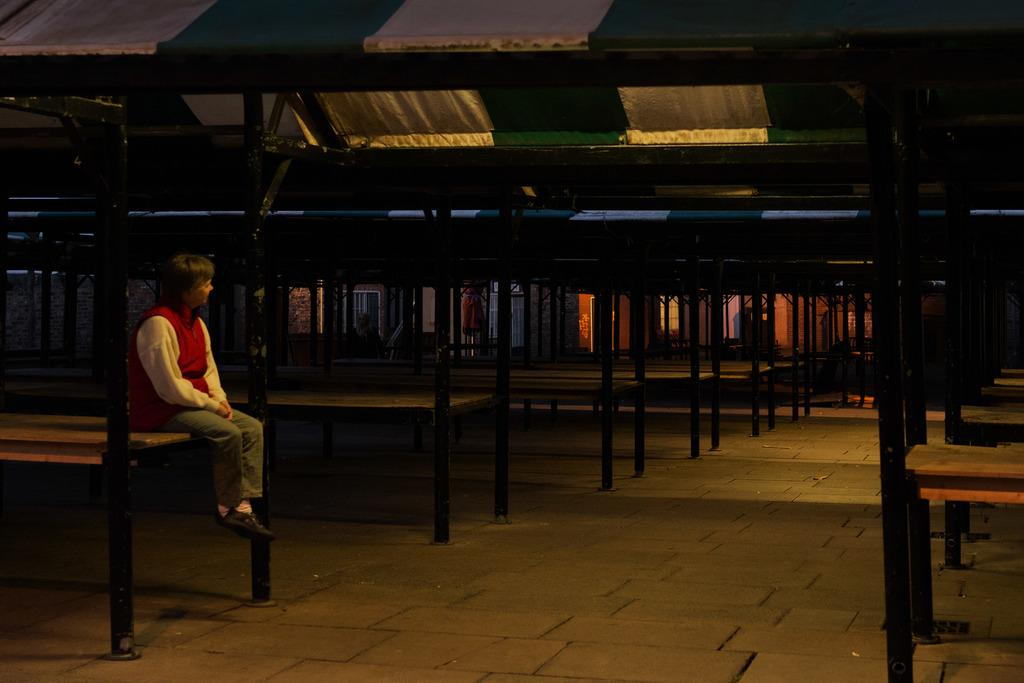What is the main subject of the image? There is a man in the image. What is the man doing in the image? The man is sitting on a bench. Can you see a cow in the image? No, there is no cow present in the image. 